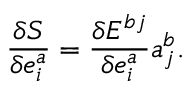<formula> <loc_0><loc_0><loc_500><loc_500>\frac { \delta S } { \delta e _ { i } ^ { a } } = \frac { \delta E ^ { b j } } { \delta e _ { i } ^ { a } } a _ { j } ^ { b } .</formula> 